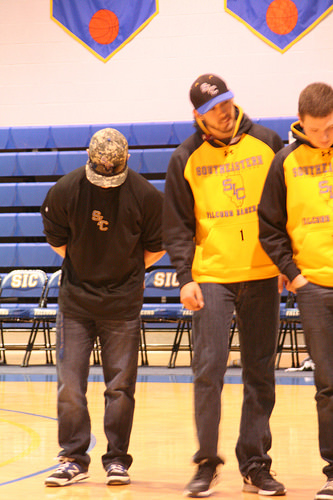<image>
Is there a wall behind the bleachers? Yes. From this viewpoint, the wall is positioned behind the bleachers, with the bleachers partially or fully occluding the wall. 